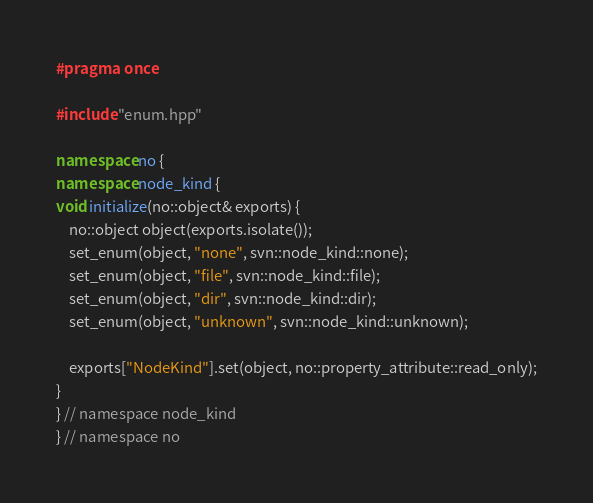Convert code to text. <code><loc_0><loc_0><loc_500><loc_500><_C++_>#pragma once

#include "enum.hpp"

namespace no {
namespace node_kind {
void initialize(no::object& exports) {
    no::object object(exports.isolate());
    set_enum(object, "none", svn::node_kind::none);
    set_enum(object, "file", svn::node_kind::file);
    set_enum(object, "dir", svn::node_kind::dir);
    set_enum(object, "unknown", svn::node_kind::unknown);

    exports["NodeKind"].set(object, no::property_attribute::read_only);
}
} // namespace node_kind
} // namespace no
</code> 